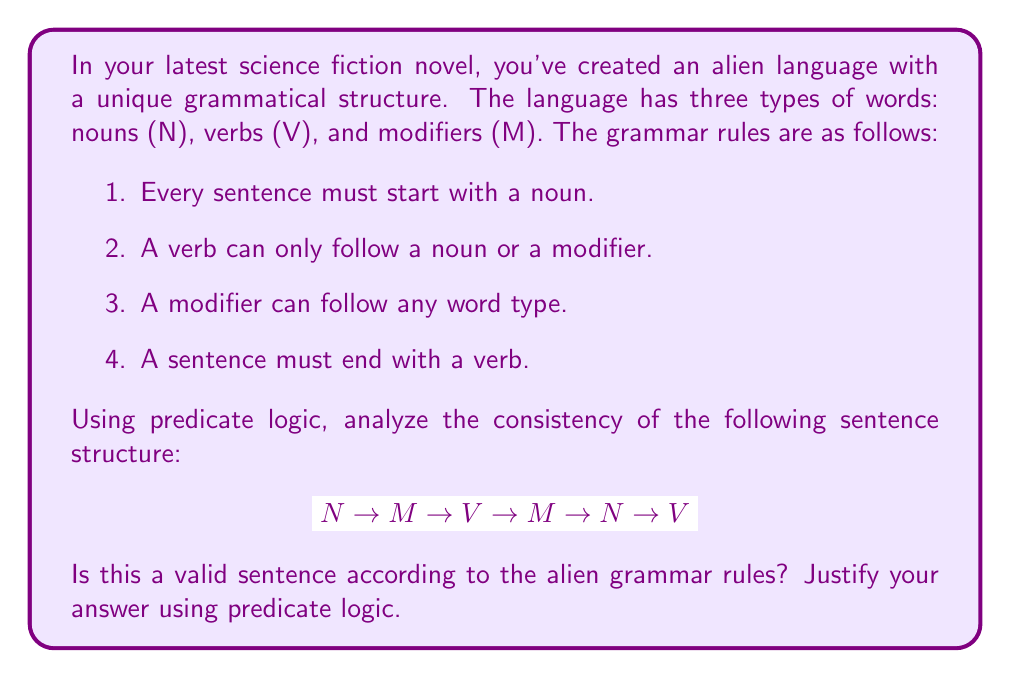Give your solution to this math problem. Let's analyze this sentence structure step by step using predicate logic:

1. Define predicates:
   $S(x)$: x is a valid sentence
   $N(x)$: x is a noun
   $V(x)$: x is a verb
   $M(x)$: x is a modifier

2. Express the grammar rules in predicate logic:
   Rule 1: $\forall x (S(x) \rightarrow N(\text{first}(x)))$
   Rule 2: $\forall x \forall y (V(y) \wedge \text{follows}(y,x) \rightarrow (N(x) \vee M(x)))$
   Rule 3: $\forall x \forall y (M(y) \wedge \text{follows}(y,x) \rightarrow (N(x) \vee V(x) \vee M(x)))$
   Rule 4: $\forall x (S(x) \rightarrow V(\text{last}(x)))$

3. Analyze the given sentence structure:
   $$ N \rightarrow M \rightarrow V \rightarrow M \rightarrow N \rightarrow V $$

   a. First word is N: Satisfies Rule 1
   b. M follows N: Satisfies Rule 3
   c. V follows M: Satisfies Rule 2
   d. M follows V: Satisfies Rule 3
   e. N follows M: Satisfies Rule 3
   f. V follows N: Satisfies Rule 2
   g. Last word is V: Satisfies Rule 4

4. Formal proof:
   Let $s$ be the given sentence structure.
   
   $N(\text{first}(s)) \wedge V(\text{last}(s))$ (satisfies Rules 1 and 4)
   
   $\forall i \in \{2,4\} (M(w_i) \wedge \text{follows}(w_i, w_{i-1}))$ (satisfies Rule 3)
   
   $\forall i \in \{3,6\} (V(w_i) \wedge (N(w_{i-1}) \vee M(w_{i-1})))$ (satisfies Rule 2)
   
   $N(w_5) \wedge \text{follows}(w_5, w_4)$ (satisfies Rule 3)

   Therefore, all rules are satisfied, and the sentence structure is consistent with the alien grammar.
Answer: Valid sentence structure 